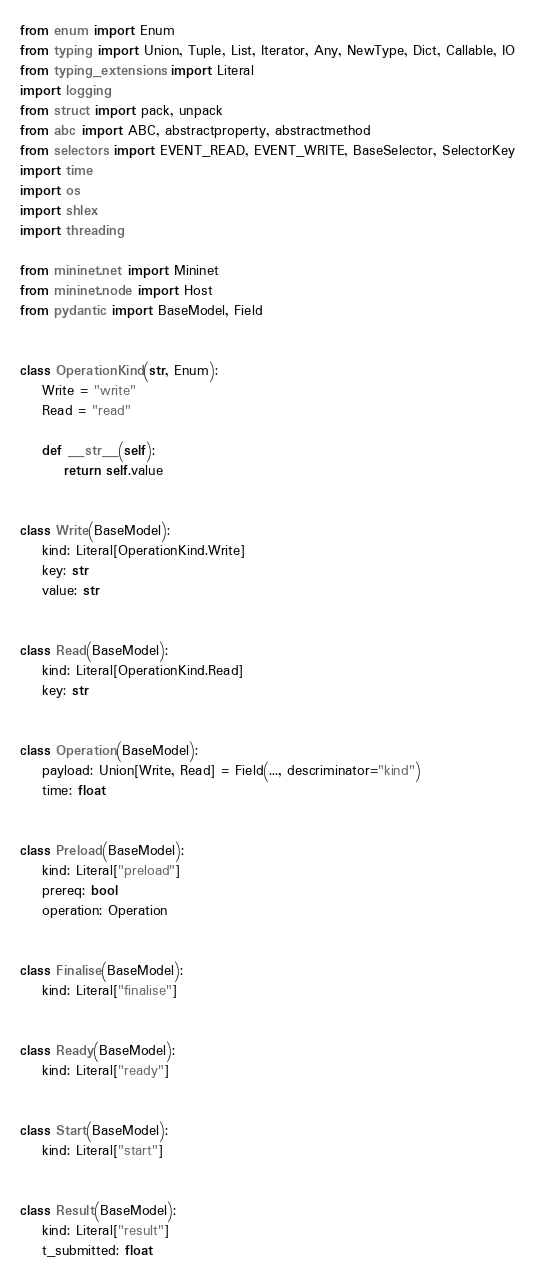<code> <loc_0><loc_0><loc_500><loc_500><_Python_>from enum import Enum
from typing import Union, Tuple, List, Iterator, Any, NewType, Dict, Callable, IO
from typing_extensions import Literal
import logging
from struct import pack, unpack
from abc import ABC, abstractproperty, abstractmethod
from selectors import EVENT_READ, EVENT_WRITE, BaseSelector, SelectorKey
import time
import os
import shlex
import threading

from mininet.net import Mininet
from mininet.node import Host
from pydantic import BaseModel, Field


class OperationKind(str, Enum):
    Write = "write"
    Read = "read"

    def __str__(self):
        return self.value


class Write(BaseModel):
    kind: Literal[OperationKind.Write]
    key: str
    value: str


class Read(BaseModel):
    kind: Literal[OperationKind.Read]
    key: str


class Operation(BaseModel):
    payload: Union[Write, Read] = Field(..., descriminator="kind")
    time: float


class Preload(BaseModel):
    kind: Literal["preload"]
    prereq: bool
    operation: Operation


class Finalise(BaseModel):
    kind: Literal["finalise"]


class Ready(BaseModel):
    kind: Literal["ready"]


class Start(BaseModel):
    kind: Literal["start"]


class Result(BaseModel):
    kind: Literal["result"]
    t_submitted: float</code> 